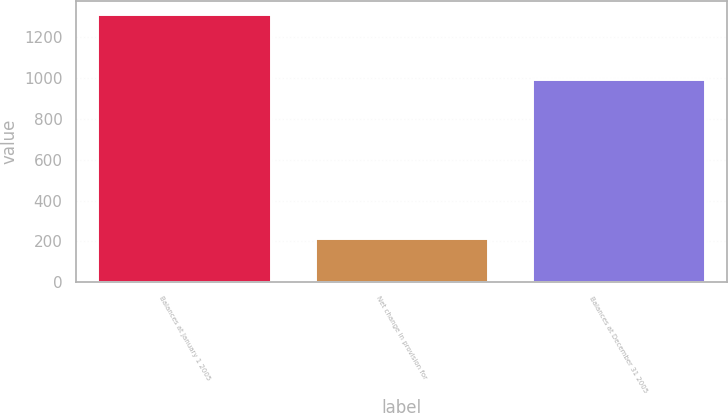Convert chart. <chart><loc_0><loc_0><loc_500><loc_500><bar_chart><fcel>Balances at January 1 2005<fcel>Net change in provision for<fcel>Balances at December 31 2005<nl><fcel>1313.3<fcel>215.4<fcel>994.8<nl></chart> 